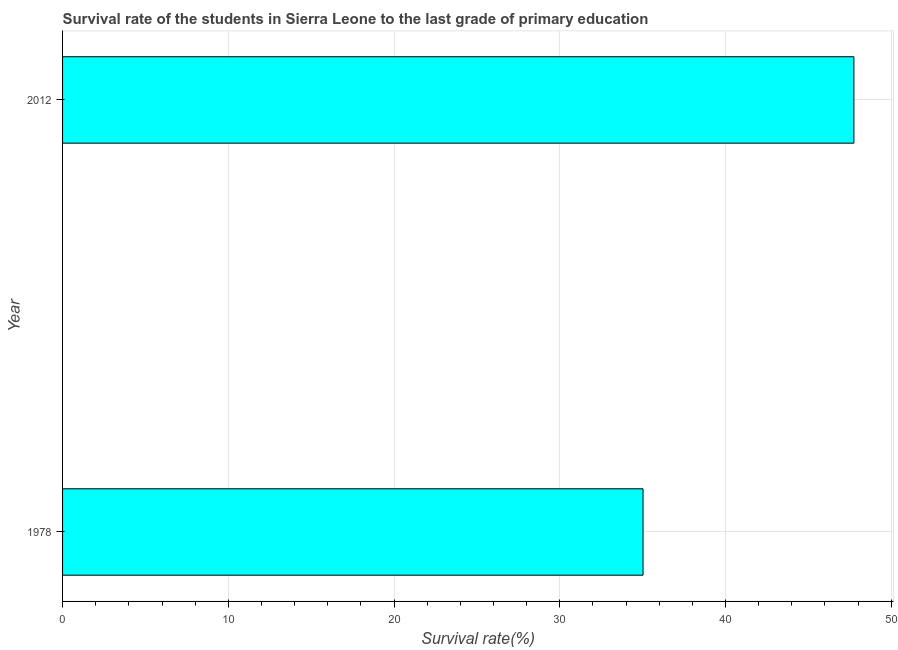Does the graph contain any zero values?
Ensure brevity in your answer.  No. Does the graph contain grids?
Provide a succinct answer. Yes. What is the title of the graph?
Provide a succinct answer. Survival rate of the students in Sierra Leone to the last grade of primary education. What is the label or title of the X-axis?
Provide a short and direct response. Survival rate(%). What is the label or title of the Y-axis?
Offer a terse response. Year. What is the survival rate in primary education in 1978?
Ensure brevity in your answer.  35.03. Across all years, what is the maximum survival rate in primary education?
Your answer should be very brief. 47.75. Across all years, what is the minimum survival rate in primary education?
Give a very brief answer. 35.03. In which year was the survival rate in primary education minimum?
Offer a terse response. 1978. What is the sum of the survival rate in primary education?
Keep it short and to the point. 82.78. What is the difference between the survival rate in primary education in 1978 and 2012?
Your answer should be compact. -12.72. What is the average survival rate in primary education per year?
Your answer should be very brief. 41.39. What is the median survival rate in primary education?
Your response must be concise. 41.39. In how many years, is the survival rate in primary education greater than 46 %?
Your answer should be very brief. 1. What is the ratio of the survival rate in primary education in 1978 to that in 2012?
Your response must be concise. 0.73. Is the survival rate in primary education in 1978 less than that in 2012?
Provide a succinct answer. Yes. Are all the bars in the graph horizontal?
Your answer should be compact. Yes. How many years are there in the graph?
Make the answer very short. 2. What is the difference between two consecutive major ticks on the X-axis?
Offer a very short reply. 10. What is the Survival rate(%) in 1978?
Provide a succinct answer. 35.03. What is the Survival rate(%) of 2012?
Make the answer very short. 47.75. What is the difference between the Survival rate(%) in 1978 and 2012?
Your answer should be compact. -12.72. What is the ratio of the Survival rate(%) in 1978 to that in 2012?
Your answer should be very brief. 0.73. 